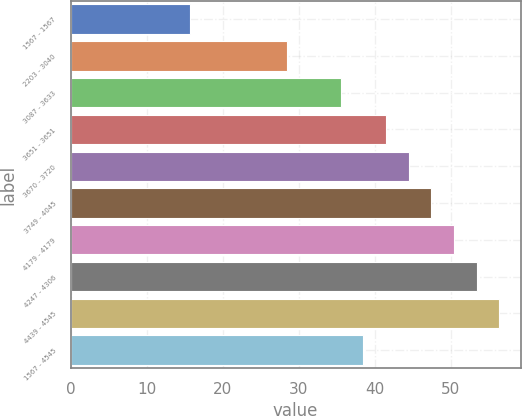Convert chart. <chart><loc_0><loc_0><loc_500><loc_500><bar_chart><fcel>1567 - 1567<fcel>2203 - 3040<fcel>3087 - 3633<fcel>3651 - 3651<fcel>3670 - 3720<fcel>3749 - 4045<fcel>4179 - 4179<fcel>4247 - 4306<fcel>4439 - 4545<fcel>1567 - 4545<nl><fcel>15.67<fcel>28.5<fcel>35.51<fcel>41.47<fcel>44.45<fcel>47.43<fcel>50.41<fcel>53.39<fcel>56.37<fcel>38.49<nl></chart> 